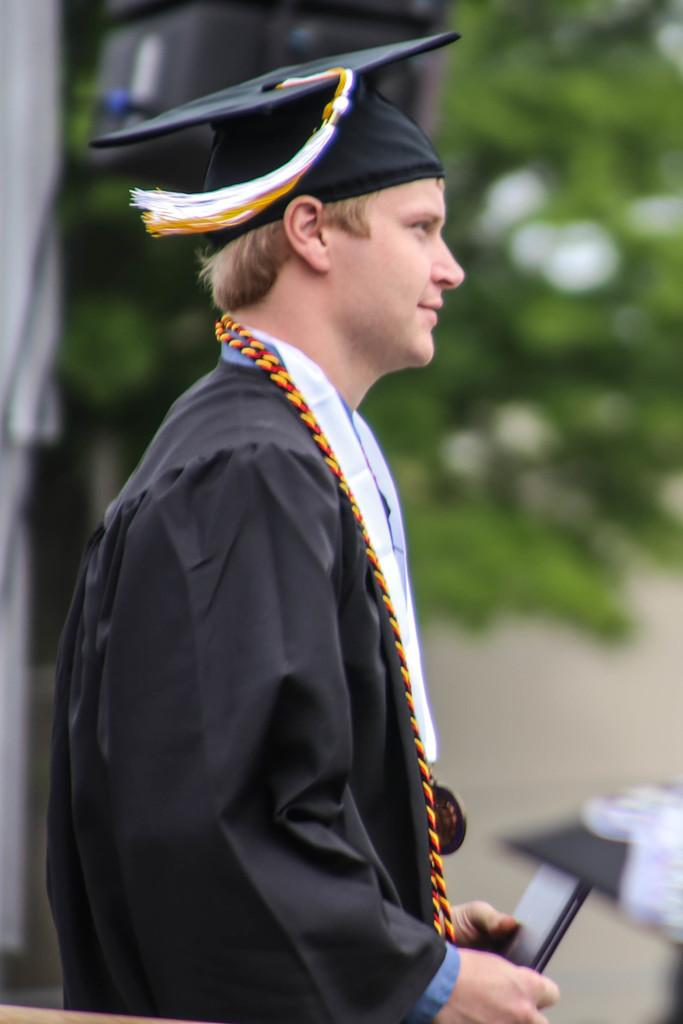Who is present in the image? There is a man in the image. What is the man wearing on his head? The man is wearing a cap. What expression does the man have? The man is smiling. What can be seen in the background of the image? There are objects and trees in the background of the image. How would you describe the background of the image? The background of the image is blurry. What type of orange is the man holding in the image? There is no orange present in the image; the man is not holding any fruit. 